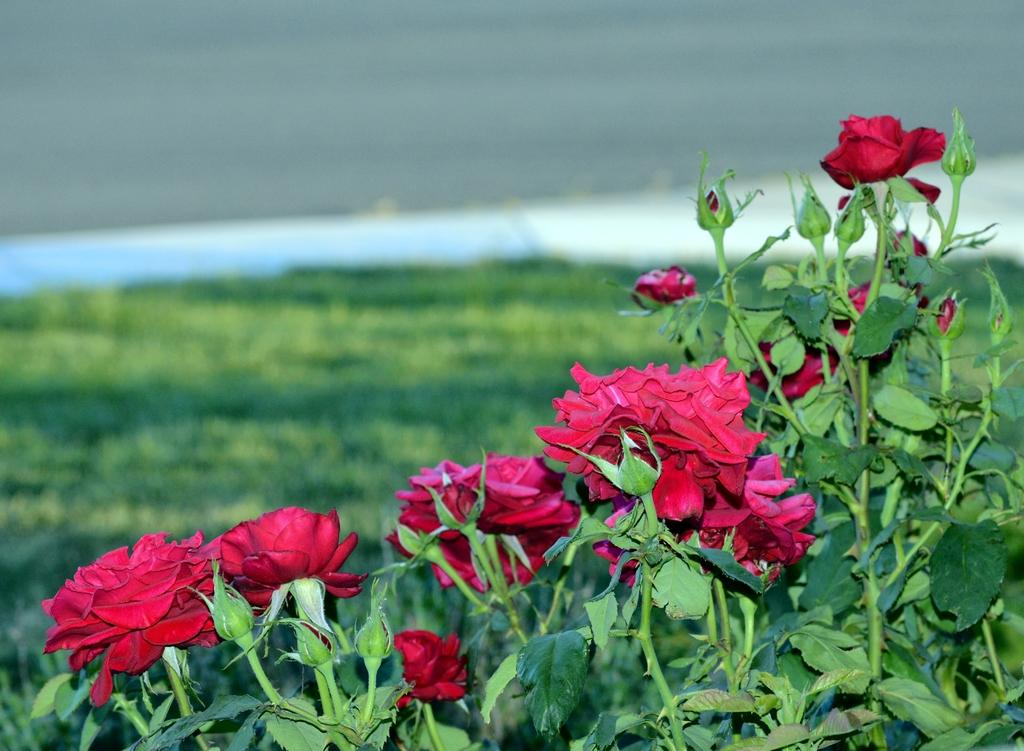What type of living organisms can be seen in the image? Plants can be seen in the image. What color are the leaves of the plants in the image? The leaves of the plants in the image are green. What type of flowers are present on the plants in the image? The plants in the image have red roses. Can you describe the background of the image? The background of the image is blurred. What time of day is it at the seashore in the image? There is no seashore present in the image, and therefore no time of day can be determined. 